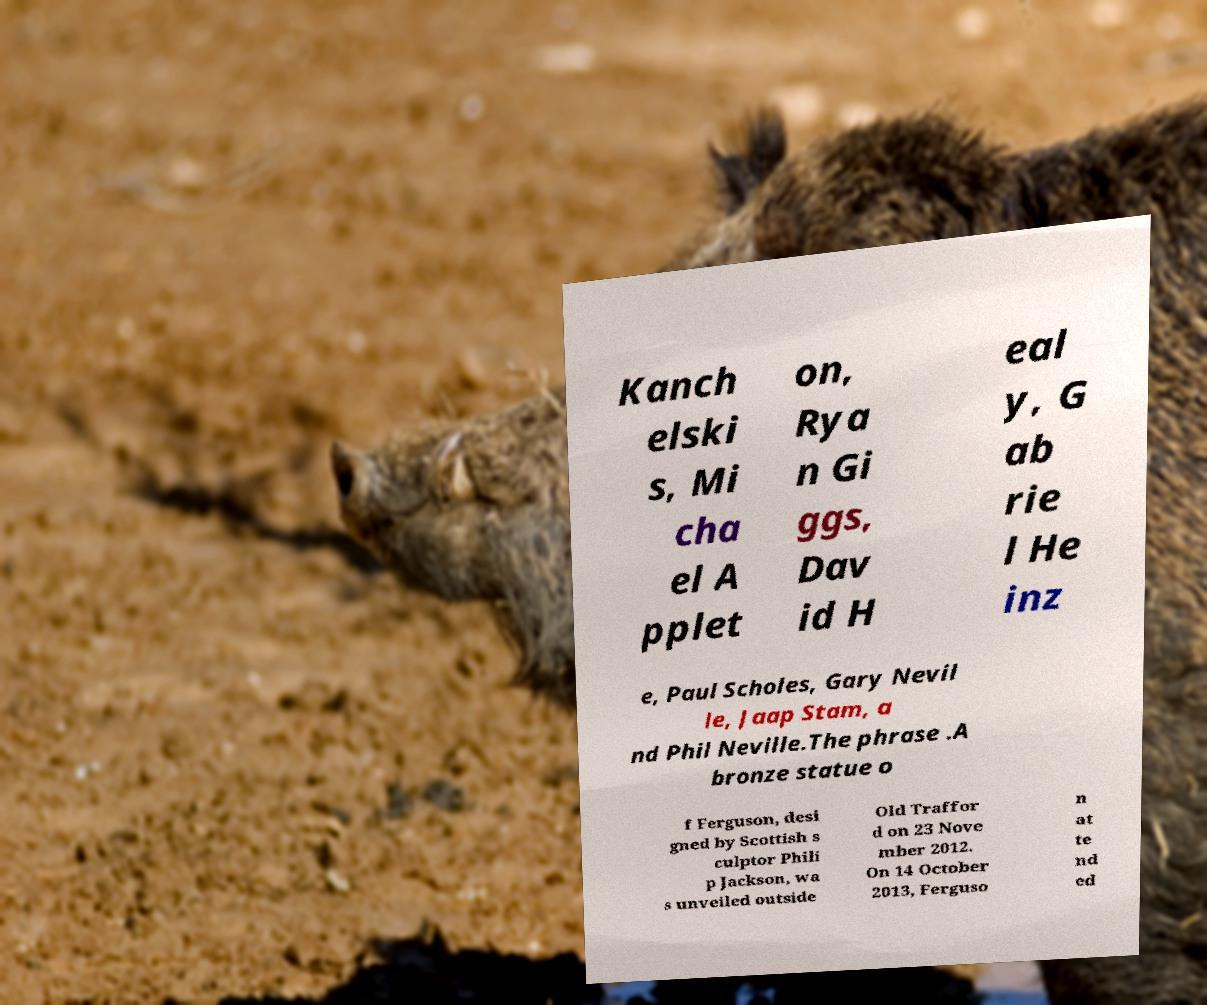There's text embedded in this image that I need extracted. Can you transcribe it verbatim? Kanch elski s, Mi cha el A pplet on, Rya n Gi ggs, Dav id H eal y, G ab rie l He inz e, Paul Scholes, Gary Nevil le, Jaap Stam, a nd Phil Neville.The phrase .A bronze statue o f Ferguson, desi gned by Scottish s culptor Phili p Jackson, wa s unveiled outside Old Traffor d on 23 Nove mber 2012. On 14 October 2013, Ferguso n at te nd ed 